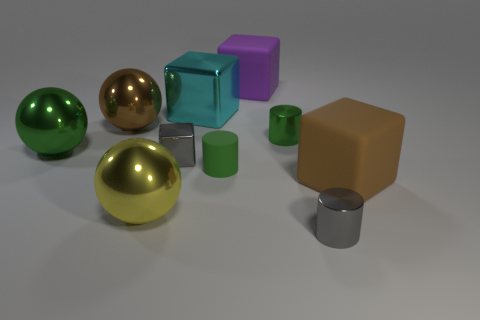Subtract all yellow balls. How many balls are left? 2 Subtract all cyan blocks. How many blocks are left? 3 Subtract 2 balls. How many balls are left? 1 Subtract all blocks. How many objects are left? 6 Subtract all large brown rubber cylinders. Subtract all cylinders. How many objects are left? 7 Add 7 green shiny objects. How many green shiny objects are left? 9 Add 4 large metallic blocks. How many large metallic blocks exist? 5 Subtract 0 purple cylinders. How many objects are left? 10 Subtract all purple blocks. Subtract all yellow spheres. How many blocks are left? 3 Subtract all cyan balls. How many gray cylinders are left? 1 